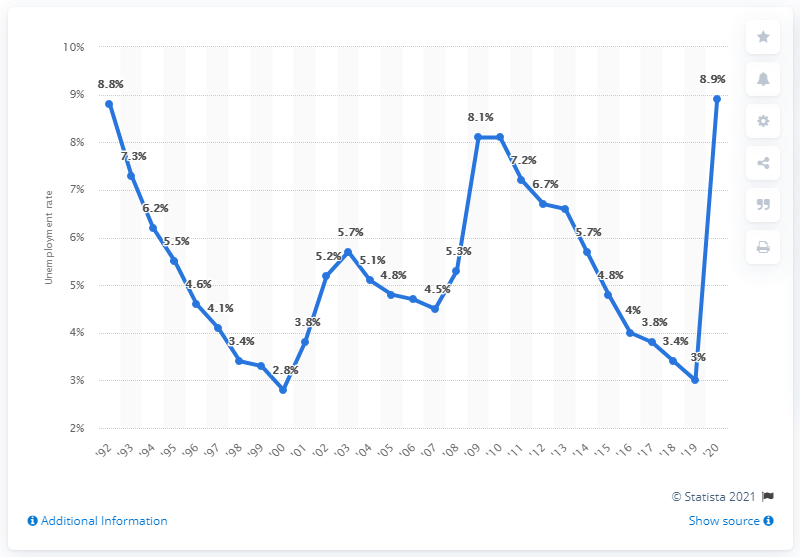Identify some key points in this picture. The unemployment rate in Massachusetts in 2020 was 8.9%. 